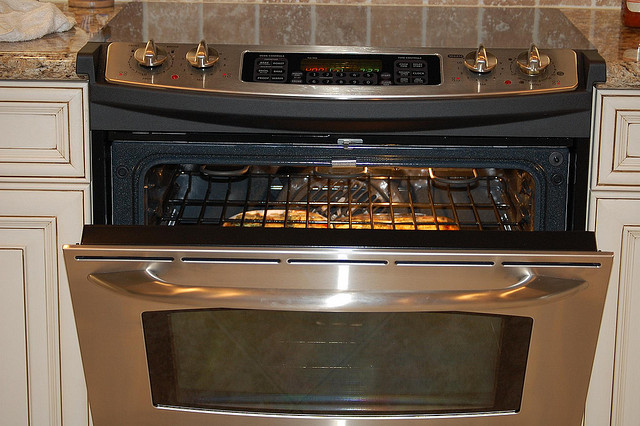<image>What kind of pizza is this? It is unknown what kind of pizza this is. It could be pepperoni, cheese, store bought, homemade, oven baked, or vegetable. What kind of pizza is this? I am not sure what kind of pizza it is. It could be pepperoni, cheese, store bought, homemade, plain, oven baked, or vegetable pizza. 